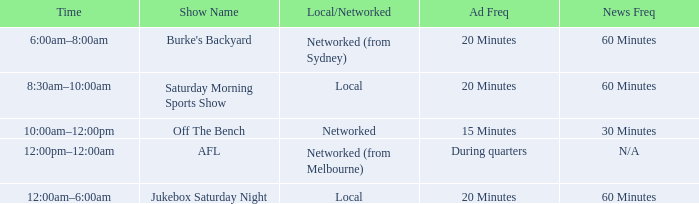What is the local/network with an Ad frequency of 15 minutes? Networked. 